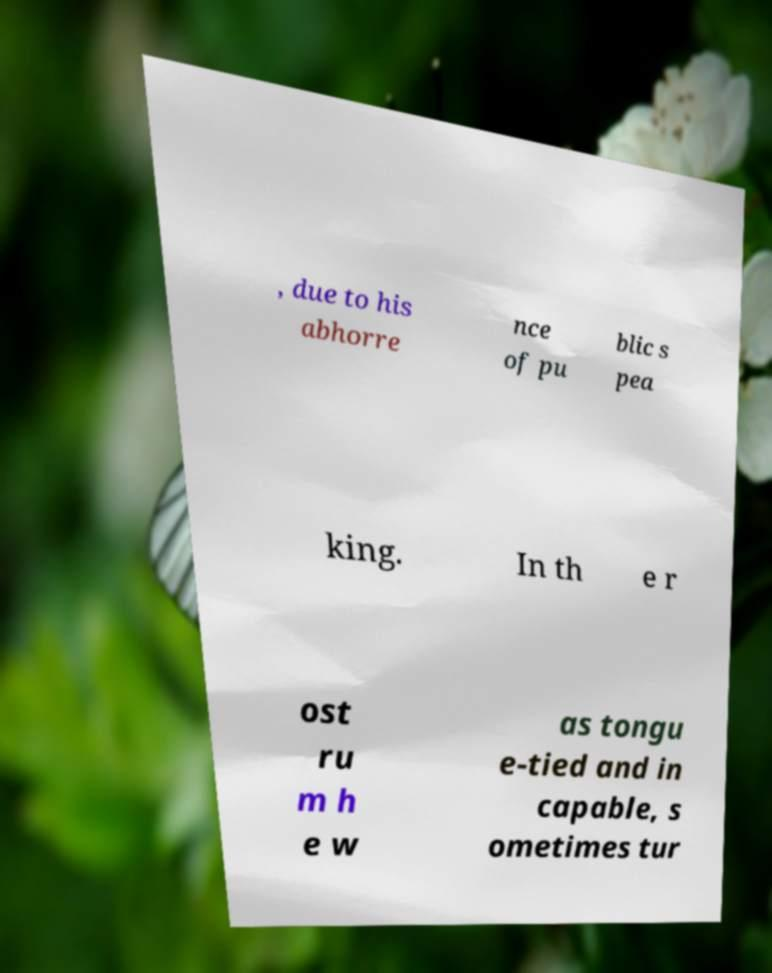What messages or text are displayed in this image? I need them in a readable, typed format. , due to his abhorre nce of pu blic s pea king. In th e r ost ru m h e w as tongu e-tied and in capable, s ometimes tur 